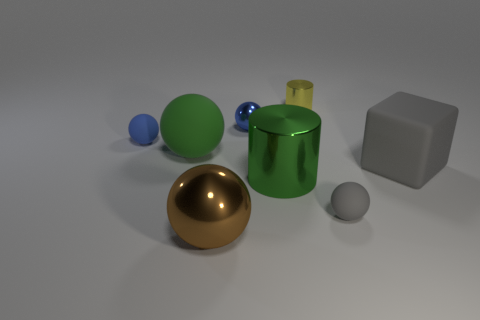Subtract all large green balls. How many balls are left? 4 Subtract all brown spheres. How many spheres are left? 4 Add 1 large metallic things. How many objects exist? 9 Subtract all cylinders. How many objects are left? 6 Subtract 4 balls. How many balls are left? 1 Subtract all gray matte cubes. Subtract all brown things. How many objects are left? 6 Add 7 small gray balls. How many small gray balls are left? 8 Add 4 large red metal cylinders. How many large red metal cylinders exist? 4 Subtract 0 brown cylinders. How many objects are left? 8 Subtract all yellow balls. Subtract all red blocks. How many balls are left? 5 